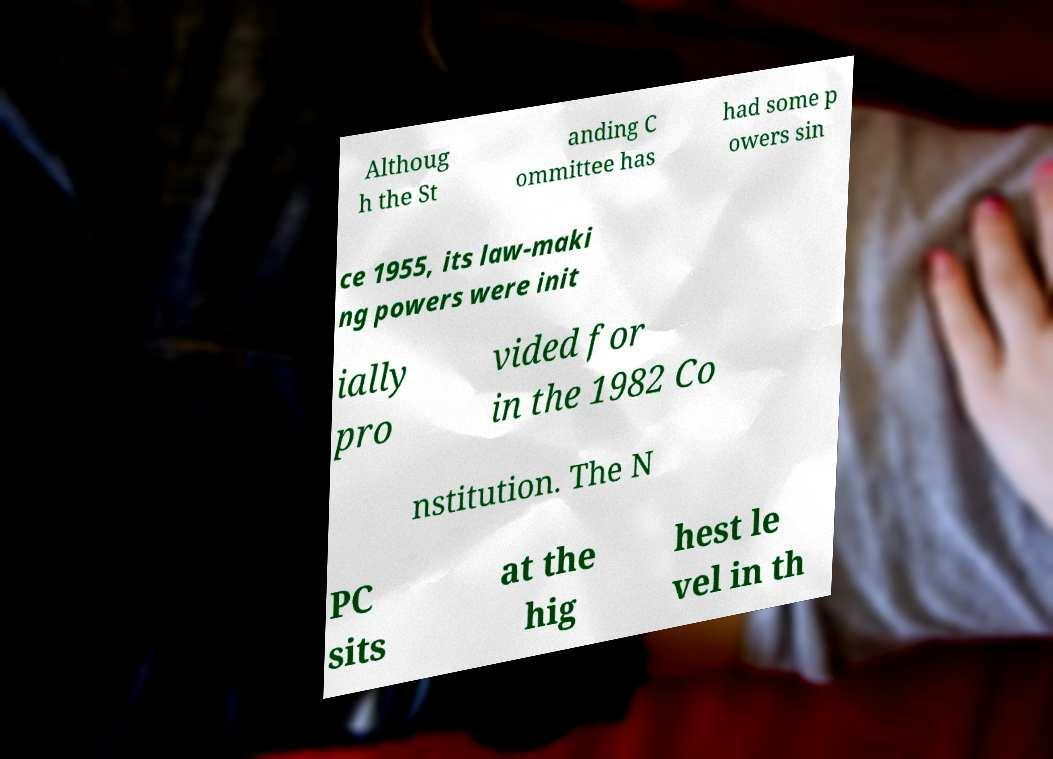Could you assist in decoding the text presented in this image and type it out clearly? Althoug h the St anding C ommittee has had some p owers sin ce 1955, its law-maki ng powers were init ially pro vided for in the 1982 Co nstitution. The N PC sits at the hig hest le vel in th 